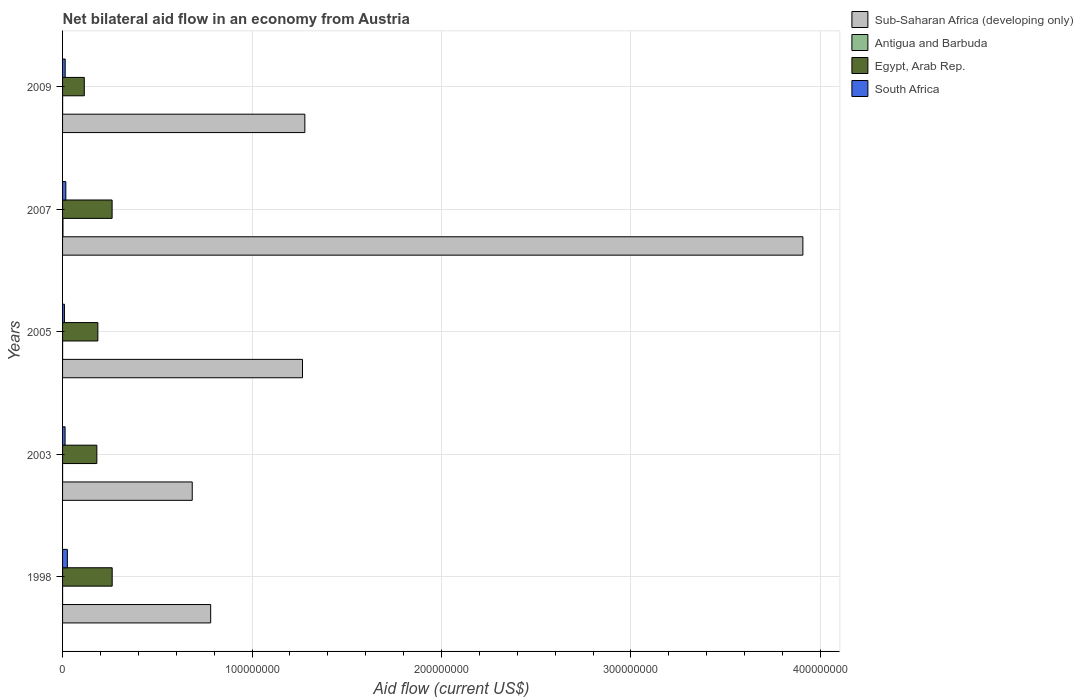How many different coloured bars are there?
Make the answer very short. 4. Are the number of bars per tick equal to the number of legend labels?
Make the answer very short. Yes. Are the number of bars on each tick of the Y-axis equal?
Ensure brevity in your answer.  Yes. How many bars are there on the 3rd tick from the top?
Give a very brief answer. 4. What is the net bilateral aid flow in South Africa in 2005?
Offer a terse response. 9.90e+05. Across all years, what is the maximum net bilateral aid flow in South Africa?
Your response must be concise. 2.54e+06. Across all years, what is the minimum net bilateral aid flow in Antigua and Barbuda?
Offer a terse response. 10000. In which year was the net bilateral aid flow in South Africa maximum?
Your answer should be very brief. 1998. In which year was the net bilateral aid flow in South Africa minimum?
Provide a short and direct response. 2005. What is the total net bilateral aid flow in Egypt, Arab Rep. in the graph?
Ensure brevity in your answer.  1.01e+08. What is the difference between the net bilateral aid flow in South Africa in 2003 and that in 2007?
Keep it short and to the point. -3.90e+05. What is the difference between the net bilateral aid flow in Sub-Saharan Africa (developing only) in 2009 and the net bilateral aid flow in Antigua and Barbuda in 2007?
Keep it short and to the point. 1.28e+08. What is the average net bilateral aid flow in Egypt, Arab Rep. per year?
Make the answer very short. 2.01e+07. In the year 2003, what is the difference between the net bilateral aid flow in Egypt, Arab Rep. and net bilateral aid flow in Antigua and Barbuda?
Keep it short and to the point. 1.81e+07. In how many years, is the net bilateral aid flow in Egypt, Arab Rep. greater than 260000000 US$?
Offer a very short reply. 0. What is the ratio of the net bilateral aid flow in Sub-Saharan Africa (developing only) in 2003 to that in 2009?
Your answer should be compact. 0.54. Is the difference between the net bilateral aid flow in Egypt, Arab Rep. in 2003 and 2005 greater than the difference between the net bilateral aid flow in Antigua and Barbuda in 2003 and 2005?
Give a very brief answer. No. What is the difference between the highest and the second highest net bilateral aid flow in Egypt, Arab Rep.?
Offer a terse response. 4.00e+04. What is the difference between the highest and the lowest net bilateral aid flow in South Africa?
Keep it short and to the point. 1.55e+06. Is the sum of the net bilateral aid flow in Antigua and Barbuda in 1998 and 2003 greater than the maximum net bilateral aid flow in Egypt, Arab Rep. across all years?
Provide a succinct answer. No. What does the 1st bar from the top in 2009 represents?
Provide a short and direct response. South Africa. What does the 3rd bar from the bottom in 2007 represents?
Provide a succinct answer. Egypt, Arab Rep. How many bars are there?
Make the answer very short. 20. Are all the bars in the graph horizontal?
Your response must be concise. Yes. What is the difference between two consecutive major ticks on the X-axis?
Offer a very short reply. 1.00e+08. Are the values on the major ticks of X-axis written in scientific E-notation?
Your answer should be very brief. No. Does the graph contain grids?
Provide a succinct answer. Yes. Where does the legend appear in the graph?
Your response must be concise. Top right. How many legend labels are there?
Make the answer very short. 4. How are the legend labels stacked?
Your answer should be very brief. Vertical. What is the title of the graph?
Make the answer very short. Net bilateral aid flow in an economy from Austria. Does "Mozambique" appear as one of the legend labels in the graph?
Your answer should be compact. No. What is the label or title of the X-axis?
Your answer should be very brief. Aid flow (current US$). What is the label or title of the Y-axis?
Your response must be concise. Years. What is the Aid flow (current US$) in Sub-Saharan Africa (developing only) in 1998?
Give a very brief answer. 7.82e+07. What is the Aid flow (current US$) in Antigua and Barbuda in 1998?
Your response must be concise. 10000. What is the Aid flow (current US$) of Egypt, Arab Rep. in 1998?
Keep it short and to the point. 2.62e+07. What is the Aid flow (current US$) of South Africa in 1998?
Your answer should be compact. 2.54e+06. What is the Aid flow (current US$) of Sub-Saharan Africa (developing only) in 2003?
Keep it short and to the point. 6.84e+07. What is the Aid flow (current US$) in Egypt, Arab Rep. in 2003?
Offer a very short reply. 1.81e+07. What is the Aid flow (current US$) in South Africa in 2003?
Give a very brief answer. 1.33e+06. What is the Aid flow (current US$) in Sub-Saharan Africa (developing only) in 2005?
Make the answer very short. 1.27e+08. What is the Aid flow (current US$) in Antigua and Barbuda in 2005?
Provide a short and direct response. 10000. What is the Aid flow (current US$) in Egypt, Arab Rep. in 2005?
Your answer should be compact. 1.86e+07. What is the Aid flow (current US$) in South Africa in 2005?
Offer a very short reply. 9.90e+05. What is the Aid flow (current US$) in Sub-Saharan Africa (developing only) in 2007?
Provide a succinct answer. 3.91e+08. What is the Aid flow (current US$) of Antigua and Barbuda in 2007?
Keep it short and to the point. 2.10e+05. What is the Aid flow (current US$) of Egypt, Arab Rep. in 2007?
Give a very brief answer. 2.62e+07. What is the Aid flow (current US$) in South Africa in 2007?
Offer a terse response. 1.72e+06. What is the Aid flow (current US$) in Sub-Saharan Africa (developing only) in 2009?
Provide a succinct answer. 1.28e+08. What is the Aid flow (current US$) in Antigua and Barbuda in 2009?
Your answer should be very brief. 2.00e+04. What is the Aid flow (current US$) in Egypt, Arab Rep. in 2009?
Offer a terse response. 1.15e+07. What is the Aid flow (current US$) of South Africa in 2009?
Make the answer very short. 1.38e+06. Across all years, what is the maximum Aid flow (current US$) of Sub-Saharan Africa (developing only)?
Your answer should be compact. 3.91e+08. Across all years, what is the maximum Aid flow (current US$) in Antigua and Barbuda?
Keep it short and to the point. 2.10e+05. Across all years, what is the maximum Aid flow (current US$) in Egypt, Arab Rep.?
Your response must be concise. 2.62e+07. Across all years, what is the maximum Aid flow (current US$) in South Africa?
Ensure brevity in your answer.  2.54e+06. Across all years, what is the minimum Aid flow (current US$) of Sub-Saharan Africa (developing only)?
Your answer should be compact. 6.84e+07. Across all years, what is the minimum Aid flow (current US$) in Egypt, Arab Rep.?
Provide a short and direct response. 1.15e+07. Across all years, what is the minimum Aid flow (current US$) in South Africa?
Ensure brevity in your answer.  9.90e+05. What is the total Aid flow (current US$) of Sub-Saharan Africa (developing only) in the graph?
Your answer should be compact. 7.92e+08. What is the total Aid flow (current US$) in Egypt, Arab Rep. in the graph?
Ensure brevity in your answer.  1.01e+08. What is the total Aid flow (current US$) of South Africa in the graph?
Ensure brevity in your answer.  7.96e+06. What is the difference between the Aid flow (current US$) of Sub-Saharan Africa (developing only) in 1998 and that in 2003?
Make the answer very short. 9.73e+06. What is the difference between the Aid flow (current US$) in Egypt, Arab Rep. in 1998 and that in 2003?
Your response must be concise. 8.10e+06. What is the difference between the Aid flow (current US$) in South Africa in 1998 and that in 2003?
Offer a terse response. 1.21e+06. What is the difference between the Aid flow (current US$) of Sub-Saharan Africa (developing only) in 1998 and that in 2005?
Give a very brief answer. -4.85e+07. What is the difference between the Aid flow (current US$) in Antigua and Barbuda in 1998 and that in 2005?
Give a very brief answer. 0. What is the difference between the Aid flow (current US$) in Egypt, Arab Rep. in 1998 and that in 2005?
Offer a terse response. 7.56e+06. What is the difference between the Aid flow (current US$) of South Africa in 1998 and that in 2005?
Keep it short and to the point. 1.55e+06. What is the difference between the Aid flow (current US$) in Sub-Saharan Africa (developing only) in 1998 and that in 2007?
Keep it short and to the point. -3.13e+08. What is the difference between the Aid flow (current US$) in Egypt, Arab Rep. in 1998 and that in 2007?
Keep it short and to the point. 4.00e+04. What is the difference between the Aid flow (current US$) in South Africa in 1998 and that in 2007?
Keep it short and to the point. 8.20e+05. What is the difference between the Aid flow (current US$) of Sub-Saharan Africa (developing only) in 1998 and that in 2009?
Your response must be concise. -4.97e+07. What is the difference between the Aid flow (current US$) in Egypt, Arab Rep. in 1998 and that in 2009?
Keep it short and to the point. 1.47e+07. What is the difference between the Aid flow (current US$) of South Africa in 1998 and that in 2009?
Keep it short and to the point. 1.16e+06. What is the difference between the Aid flow (current US$) of Sub-Saharan Africa (developing only) in 2003 and that in 2005?
Ensure brevity in your answer.  -5.82e+07. What is the difference between the Aid flow (current US$) in Egypt, Arab Rep. in 2003 and that in 2005?
Your response must be concise. -5.40e+05. What is the difference between the Aid flow (current US$) of South Africa in 2003 and that in 2005?
Keep it short and to the point. 3.40e+05. What is the difference between the Aid flow (current US$) of Sub-Saharan Africa (developing only) in 2003 and that in 2007?
Offer a terse response. -3.22e+08. What is the difference between the Aid flow (current US$) of Antigua and Barbuda in 2003 and that in 2007?
Provide a succinct answer. -2.00e+05. What is the difference between the Aid flow (current US$) of Egypt, Arab Rep. in 2003 and that in 2007?
Provide a short and direct response. -8.06e+06. What is the difference between the Aid flow (current US$) of South Africa in 2003 and that in 2007?
Offer a very short reply. -3.90e+05. What is the difference between the Aid flow (current US$) of Sub-Saharan Africa (developing only) in 2003 and that in 2009?
Make the answer very short. -5.94e+07. What is the difference between the Aid flow (current US$) in Antigua and Barbuda in 2003 and that in 2009?
Offer a terse response. -10000. What is the difference between the Aid flow (current US$) in Egypt, Arab Rep. in 2003 and that in 2009?
Make the answer very short. 6.62e+06. What is the difference between the Aid flow (current US$) in South Africa in 2003 and that in 2009?
Provide a short and direct response. -5.00e+04. What is the difference between the Aid flow (current US$) of Sub-Saharan Africa (developing only) in 2005 and that in 2007?
Provide a short and direct response. -2.64e+08. What is the difference between the Aid flow (current US$) in Antigua and Barbuda in 2005 and that in 2007?
Offer a terse response. -2.00e+05. What is the difference between the Aid flow (current US$) in Egypt, Arab Rep. in 2005 and that in 2007?
Your answer should be very brief. -7.52e+06. What is the difference between the Aid flow (current US$) of South Africa in 2005 and that in 2007?
Give a very brief answer. -7.30e+05. What is the difference between the Aid flow (current US$) in Sub-Saharan Africa (developing only) in 2005 and that in 2009?
Offer a very short reply. -1.24e+06. What is the difference between the Aid flow (current US$) in Egypt, Arab Rep. in 2005 and that in 2009?
Ensure brevity in your answer.  7.16e+06. What is the difference between the Aid flow (current US$) in South Africa in 2005 and that in 2009?
Give a very brief answer. -3.90e+05. What is the difference between the Aid flow (current US$) of Sub-Saharan Africa (developing only) in 2007 and that in 2009?
Offer a terse response. 2.63e+08. What is the difference between the Aid flow (current US$) in Antigua and Barbuda in 2007 and that in 2009?
Your response must be concise. 1.90e+05. What is the difference between the Aid flow (current US$) of Egypt, Arab Rep. in 2007 and that in 2009?
Your answer should be compact. 1.47e+07. What is the difference between the Aid flow (current US$) of Sub-Saharan Africa (developing only) in 1998 and the Aid flow (current US$) of Antigua and Barbuda in 2003?
Make the answer very short. 7.82e+07. What is the difference between the Aid flow (current US$) of Sub-Saharan Africa (developing only) in 1998 and the Aid flow (current US$) of Egypt, Arab Rep. in 2003?
Make the answer very short. 6.01e+07. What is the difference between the Aid flow (current US$) in Sub-Saharan Africa (developing only) in 1998 and the Aid flow (current US$) in South Africa in 2003?
Ensure brevity in your answer.  7.68e+07. What is the difference between the Aid flow (current US$) in Antigua and Barbuda in 1998 and the Aid flow (current US$) in Egypt, Arab Rep. in 2003?
Provide a succinct answer. -1.81e+07. What is the difference between the Aid flow (current US$) in Antigua and Barbuda in 1998 and the Aid flow (current US$) in South Africa in 2003?
Your answer should be compact. -1.32e+06. What is the difference between the Aid flow (current US$) of Egypt, Arab Rep. in 1998 and the Aid flow (current US$) of South Africa in 2003?
Provide a succinct answer. 2.49e+07. What is the difference between the Aid flow (current US$) of Sub-Saharan Africa (developing only) in 1998 and the Aid flow (current US$) of Antigua and Barbuda in 2005?
Keep it short and to the point. 7.82e+07. What is the difference between the Aid flow (current US$) in Sub-Saharan Africa (developing only) in 1998 and the Aid flow (current US$) in Egypt, Arab Rep. in 2005?
Offer a terse response. 5.95e+07. What is the difference between the Aid flow (current US$) of Sub-Saharan Africa (developing only) in 1998 and the Aid flow (current US$) of South Africa in 2005?
Your response must be concise. 7.72e+07. What is the difference between the Aid flow (current US$) in Antigua and Barbuda in 1998 and the Aid flow (current US$) in Egypt, Arab Rep. in 2005?
Offer a terse response. -1.86e+07. What is the difference between the Aid flow (current US$) in Antigua and Barbuda in 1998 and the Aid flow (current US$) in South Africa in 2005?
Make the answer very short. -9.80e+05. What is the difference between the Aid flow (current US$) of Egypt, Arab Rep. in 1998 and the Aid flow (current US$) of South Africa in 2005?
Keep it short and to the point. 2.52e+07. What is the difference between the Aid flow (current US$) of Sub-Saharan Africa (developing only) in 1998 and the Aid flow (current US$) of Antigua and Barbuda in 2007?
Your answer should be compact. 7.80e+07. What is the difference between the Aid flow (current US$) of Sub-Saharan Africa (developing only) in 1998 and the Aid flow (current US$) of Egypt, Arab Rep. in 2007?
Offer a very short reply. 5.20e+07. What is the difference between the Aid flow (current US$) in Sub-Saharan Africa (developing only) in 1998 and the Aid flow (current US$) in South Africa in 2007?
Give a very brief answer. 7.64e+07. What is the difference between the Aid flow (current US$) of Antigua and Barbuda in 1998 and the Aid flow (current US$) of Egypt, Arab Rep. in 2007?
Provide a succinct answer. -2.61e+07. What is the difference between the Aid flow (current US$) in Antigua and Barbuda in 1998 and the Aid flow (current US$) in South Africa in 2007?
Offer a terse response. -1.71e+06. What is the difference between the Aid flow (current US$) in Egypt, Arab Rep. in 1998 and the Aid flow (current US$) in South Africa in 2007?
Your answer should be compact. 2.45e+07. What is the difference between the Aid flow (current US$) of Sub-Saharan Africa (developing only) in 1998 and the Aid flow (current US$) of Antigua and Barbuda in 2009?
Provide a short and direct response. 7.82e+07. What is the difference between the Aid flow (current US$) in Sub-Saharan Africa (developing only) in 1998 and the Aid flow (current US$) in Egypt, Arab Rep. in 2009?
Provide a succinct answer. 6.67e+07. What is the difference between the Aid flow (current US$) in Sub-Saharan Africa (developing only) in 1998 and the Aid flow (current US$) in South Africa in 2009?
Ensure brevity in your answer.  7.68e+07. What is the difference between the Aid flow (current US$) in Antigua and Barbuda in 1998 and the Aid flow (current US$) in Egypt, Arab Rep. in 2009?
Your answer should be very brief. -1.15e+07. What is the difference between the Aid flow (current US$) in Antigua and Barbuda in 1998 and the Aid flow (current US$) in South Africa in 2009?
Provide a short and direct response. -1.37e+06. What is the difference between the Aid flow (current US$) in Egypt, Arab Rep. in 1998 and the Aid flow (current US$) in South Africa in 2009?
Offer a very short reply. 2.48e+07. What is the difference between the Aid flow (current US$) of Sub-Saharan Africa (developing only) in 2003 and the Aid flow (current US$) of Antigua and Barbuda in 2005?
Your response must be concise. 6.84e+07. What is the difference between the Aid flow (current US$) of Sub-Saharan Africa (developing only) in 2003 and the Aid flow (current US$) of Egypt, Arab Rep. in 2005?
Your answer should be compact. 4.98e+07. What is the difference between the Aid flow (current US$) of Sub-Saharan Africa (developing only) in 2003 and the Aid flow (current US$) of South Africa in 2005?
Give a very brief answer. 6.74e+07. What is the difference between the Aid flow (current US$) in Antigua and Barbuda in 2003 and the Aid flow (current US$) in Egypt, Arab Rep. in 2005?
Provide a short and direct response. -1.86e+07. What is the difference between the Aid flow (current US$) in Antigua and Barbuda in 2003 and the Aid flow (current US$) in South Africa in 2005?
Your response must be concise. -9.80e+05. What is the difference between the Aid flow (current US$) of Egypt, Arab Rep. in 2003 and the Aid flow (current US$) of South Africa in 2005?
Keep it short and to the point. 1.71e+07. What is the difference between the Aid flow (current US$) in Sub-Saharan Africa (developing only) in 2003 and the Aid flow (current US$) in Antigua and Barbuda in 2007?
Keep it short and to the point. 6.82e+07. What is the difference between the Aid flow (current US$) of Sub-Saharan Africa (developing only) in 2003 and the Aid flow (current US$) of Egypt, Arab Rep. in 2007?
Give a very brief answer. 4.23e+07. What is the difference between the Aid flow (current US$) of Sub-Saharan Africa (developing only) in 2003 and the Aid flow (current US$) of South Africa in 2007?
Ensure brevity in your answer.  6.67e+07. What is the difference between the Aid flow (current US$) in Antigua and Barbuda in 2003 and the Aid flow (current US$) in Egypt, Arab Rep. in 2007?
Provide a succinct answer. -2.61e+07. What is the difference between the Aid flow (current US$) of Antigua and Barbuda in 2003 and the Aid flow (current US$) of South Africa in 2007?
Your answer should be compact. -1.71e+06. What is the difference between the Aid flow (current US$) of Egypt, Arab Rep. in 2003 and the Aid flow (current US$) of South Africa in 2007?
Provide a short and direct response. 1.64e+07. What is the difference between the Aid flow (current US$) in Sub-Saharan Africa (developing only) in 2003 and the Aid flow (current US$) in Antigua and Barbuda in 2009?
Keep it short and to the point. 6.84e+07. What is the difference between the Aid flow (current US$) of Sub-Saharan Africa (developing only) in 2003 and the Aid flow (current US$) of Egypt, Arab Rep. in 2009?
Keep it short and to the point. 5.70e+07. What is the difference between the Aid flow (current US$) in Sub-Saharan Africa (developing only) in 2003 and the Aid flow (current US$) in South Africa in 2009?
Keep it short and to the point. 6.71e+07. What is the difference between the Aid flow (current US$) in Antigua and Barbuda in 2003 and the Aid flow (current US$) in Egypt, Arab Rep. in 2009?
Ensure brevity in your answer.  -1.15e+07. What is the difference between the Aid flow (current US$) in Antigua and Barbuda in 2003 and the Aid flow (current US$) in South Africa in 2009?
Give a very brief answer. -1.37e+06. What is the difference between the Aid flow (current US$) in Egypt, Arab Rep. in 2003 and the Aid flow (current US$) in South Africa in 2009?
Keep it short and to the point. 1.67e+07. What is the difference between the Aid flow (current US$) of Sub-Saharan Africa (developing only) in 2005 and the Aid flow (current US$) of Antigua and Barbuda in 2007?
Ensure brevity in your answer.  1.26e+08. What is the difference between the Aid flow (current US$) in Sub-Saharan Africa (developing only) in 2005 and the Aid flow (current US$) in Egypt, Arab Rep. in 2007?
Offer a very short reply. 1.00e+08. What is the difference between the Aid flow (current US$) of Sub-Saharan Africa (developing only) in 2005 and the Aid flow (current US$) of South Africa in 2007?
Provide a succinct answer. 1.25e+08. What is the difference between the Aid flow (current US$) in Antigua and Barbuda in 2005 and the Aid flow (current US$) in Egypt, Arab Rep. in 2007?
Your response must be concise. -2.61e+07. What is the difference between the Aid flow (current US$) in Antigua and Barbuda in 2005 and the Aid flow (current US$) in South Africa in 2007?
Give a very brief answer. -1.71e+06. What is the difference between the Aid flow (current US$) in Egypt, Arab Rep. in 2005 and the Aid flow (current US$) in South Africa in 2007?
Give a very brief answer. 1.69e+07. What is the difference between the Aid flow (current US$) of Sub-Saharan Africa (developing only) in 2005 and the Aid flow (current US$) of Antigua and Barbuda in 2009?
Your answer should be compact. 1.27e+08. What is the difference between the Aid flow (current US$) in Sub-Saharan Africa (developing only) in 2005 and the Aid flow (current US$) in Egypt, Arab Rep. in 2009?
Your answer should be compact. 1.15e+08. What is the difference between the Aid flow (current US$) of Sub-Saharan Africa (developing only) in 2005 and the Aid flow (current US$) of South Africa in 2009?
Provide a short and direct response. 1.25e+08. What is the difference between the Aid flow (current US$) in Antigua and Barbuda in 2005 and the Aid flow (current US$) in Egypt, Arab Rep. in 2009?
Provide a succinct answer. -1.15e+07. What is the difference between the Aid flow (current US$) in Antigua and Barbuda in 2005 and the Aid flow (current US$) in South Africa in 2009?
Give a very brief answer. -1.37e+06. What is the difference between the Aid flow (current US$) of Egypt, Arab Rep. in 2005 and the Aid flow (current US$) of South Africa in 2009?
Offer a very short reply. 1.72e+07. What is the difference between the Aid flow (current US$) of Sub-Saharan Africa (developing only) in 2007 and the Aid flow (current US$) of Antigua and Barbuda in 2009?
Give a very brief answer. 3.91e+08. What is the difference between the Aid flow (current US$) of Sub-Saharan Africa (developing only) in 2007 and the Aid flow (current US$) of Egypt, Arab Rep. in 2009?
Give a very brief answer. 3.79e+08. What is the difference between the Aid flow (current US$) of Sub-Saharan Africa (developing only) in 2007 and the Aid flow (current US$) of South Africa in 2009?
Ensure brevity in your answer.  3.89e+08. What is the difference between the Aid flow (current US$) in Antigua and Barbuda in 2007 and the Aid flow (current US$) in Egypt, Arab Rep. in 2009?
Provide a short and direct response. -1.13e+07. What is the difference between the Aid flow (current US$) of Antigua and Barbuda in 2007 and the Aid flow (current US$) of South Africa in 2009?
Your answer should be very brief. -1.17e+06. What is the difference between the Aid flow (current US$) of Egypt, Arab Rep. in 2007 and the Aid flow (current US$) of South Africa in 2009?
Provide a short and direct response. 2.48e+07. What is the average Aid flow (current US$) of Sub-Saharan Africa (developing only) per year?
Provide a short and direct response. 1.58e+08. What is the average Aid flow (current US$) of Antigua and Barbuda per year?
Give a very brief answer. 5.20e+04. What is the average Aid flow (current US$) in Egypt, Arab Rep. per year?
Your answer should be very brief. 2.01e+07. What is the average Aid flow (current US$) of South Africa per year?
Your response must be concise. 1.59e+06. In the year 1998, what is the difference between the Aid flow (current US$) in Sub-Saharan Africa (developing only) and Aid flow (current US$) in Antigua and Barbuda?
Your answer should be compact. 7.82e+07. In the year 1998, what is the difference between the Aid flow (current US$) of Sub-Saharan Africa (developing only) and Aid flow (current US$) of Egypt, Arab Rep.?
Make the answer very short. 5.20e+07. In the year 1998, what is the difference between the Aid flow (current US$) of Sub-Saharan Africa (developing only) and Aid flow (current US$) of South Africa?
Keep it short and to the point. 7.56e+07. In the year 1998, what is the difference between the Aid flow (current US$) of Antigua and Barbuda and Aid flow (current US$) of Egypt, Arab Rep.?
Your answer should be very brief. -2.62e+07. In the year 1998, what is the difference between the Aid flow (current US$) of Antigua and Barbuda and Aid flow (current US$) of South Africa?
Your answer should be very brief. -2.53e+06. In the year 1998, what is the difference between the Aid flow (current US$) of Egypt, Arab Rep. and Aid flow (current US$) of South Africa?
Offer a terse response. 2.36e+07. In the year 2003, what is the difference between the Aid flow (current US$) in Sub-Saharan Africa (developing only) and Aid flow (current US$) in Antigua and Barbuda?
Provide a short and direct response. 6.84e+07. In the year 2003, what is the difference between the Aid flow (current US$) in Sub-Saharan Africa (developing only) and Aid flow (current US$) in Egypt, Arab Rep.?
Keep it short and to the point. 5.04e+07. In the year 2003, what is the difference between the Aid flow (current US$) of Sub-Saharan Africa (developing only) and Aid flow (current US$) of South Africa?
Provide a short and direct response. 6.71e+07. In the year 2003, what is the difference between the Aid flow (current US$) in Antigua and Barbuda and Aid flow (current US$) in Egypt, Arab Rep.?
Your response must be concise. -1.81e+07. In the year 2003, what is the difference between the Aid flow (current US$) of Antigua and Barbuda and Aid flow (current US$) of South Africa?
Provide a short and direct response. -1.32e+06. In the year 2003, what is the difference between the Aid flow (current US$) in Egypt, Arab Rep. and Aid flow (current US$) in South Africa?
Give a very brief answer. 1.68e+07. In the year 2005, what is the difference between the Aid flow (current US$) in Sub-Saharan Africa (developing only) and Aid flow (current US$) in Antigua and Barbuda?
Give a very brief answer. 1.27e+08. In the year 2005, what is the difference between the Aid flow (current US$) in Sub-Saharan Africa (developing only) and Aid flow (current US$) in Egypt, Arab Rep.?
Make the answer very short. 1.08e+08. In the year 2005, what is the difference between the Aid flow (current US$) in Sub-Saharan Africa (developing only) and Aid flow (current US$) in South Africa?
Offer a terse response. 1.26e+08. In the year 2005, what is the difference between the Aid flow (current US$) of Antigua and Barbuda and Aid flow (current US$) of Egypt, Arab Rep.?
Make the answer very short. -1.86e+07. In the year 2005, what is the difference between the Aid flow (current US$) of Antigua and Barbuda and Aid flow (current US$) of South Africa?
Ensure brevity in your answer.  -9.80e+05. In the year 2005, what is the difference between the Aid flow (current US$) in Egypt, Arab Rep. and Aid flow (current US$) in South Africa?
Provide a short and direct response. 1.76e+07. In the year 2007, what is the difference between the Aid flow (current US$) of Sub-Saharan Africa (developing only) and Aid flow (current US$) of Antigua and Barbuda?
Provide a succinct answer. 3.91e+08. In the year 2007, what is the difference between the Aid flow (current US$) in Sub-Saharan Africa (developing only) and Aid flow (current US$) in Egypt, Arab Rep.?
Offer a very short reply. 3.65e+08. In the year 2007, what is the difference between the Aid flow (current US$) of Sub-Saharan Africa (developing only) and Aid flow (current US$) of South Africa?
Provide a short and direct response. 3.89e+08. In the year 2007, what is the difference between the Aid flow (current US$) in Antigua and Barbuda and Aid flow (current US$) in Egypt, Arab Rep.?
Keep it short and to the point. -2.59e+07. In the year 2007, what is the difference between the Aid flow (current US$) in Antigua and Barbuda and Aid flow (current US$) in South Africa?
Offer a terse response. -1.51e+06. In the year 2007, what is the difference between the Aid flow (current US$) in Egypt, Arab Rep. and Aid flow (current US$) in South Africa?
Provide a succinct answer. 2.44e+07. In the year 2009, what is the difference between the Aid flow (current US$) in Sub-Saharan Africa (developing only) and Aid flow (current US$) in Antigua and Barbuda?
Make the answer very short. 1.28e+08. In the year 2009, what is the difference between the Aid flow (current US$) in Sub-Saharan Africa (developing only) and Aid flow (current US$) in Egypt, Arab Rep.?
Offer a very short reply. 1.16e+08. In the year 2009, what is the difference between the Aid flow (current US$) of Sub-Saharan Africa (developing only) and Aid flow (current US$) of South Africa?
Make the answer very short. 1.26e+08. In the year 2009, what is the difference between the Aid flow (current US$) in Antigua and Barbuda and Aid flow (current US$) in Egypt, Arab Rep.?
Keep it short and to the point. -1.14e+07. In the year 2009, what is the difference between the Aid flow (current US$) in Antigua and Barbuda and Aid flow (current US$) in South Africa?
Keep it short and to the point. -1.36e+06. In the year 2009, what is the difference between the Aid flow (current US$) of Egypt, Arab Rep. and Aid flow (current US$) of South Africa?
Your answer should be very brief. 1.01e+07. What is the ratio of the Aid flow (current US$) of Sub-Saharan Africa (developing only) in 1998 to that in 2003?
Give a very brief answer. 1.14. What is the ratio of the Aid flow (current US$) of Antigua and Barbuda in 1998 to that in 2003?
Make the answer very short. 1. What is the ratio of the Aid flow (current US$) in Egypt, Arab Rep. in 1998 to that in 2003?
Your answer should be compact. 1.45. What is the ratio of the Aid flow (current US$) in South Africa in 1998 to that in 2003?
Offer a very short reply. 1.91. What is the ratio of the Aid flow (current US$) in Sub-Saharan Africa (developing only) in 1998 to that in 2005?
Ensure brevity in your answer.  0.62. What is the ratio of the Aid flow (current US$) in Egypt, Arab Rep. in 1998 to that in 2005?
Ensure brevity in your answer.  1.41. What is the ratio of the Aid flow (current US$) of South Africa in 1998 to that in 2005?
Make the answer very short. 2.57. What is the ratio of the Aid flow (current US$) of Sub-Saharan Africa (developing only) in 1998 to that in 2007?
Offer a very short reply. 0.2. What is the ratio of the Aid flow (current US$) in Antigua and Barbuda in 1998 to that in 2007?
Your response must be concise. 0.05. What is the ratio of the Aid flow (current US$) of South Africa in 1998 to that in 2007?
Give a very brief answer. 1.48. What is the ratio of the Aid flow (current US$) in Sub-Saharan Africa (developing only) in 1998 to that in 2009?
Keep it short and to the point. 0.61. What is the ratio of the Aid flow (current US$) in Egypt, Arab Rep. in 1998 to that in 2009?
Make the answer very short. 2.28. What is the ratio of the Aid flow (current US$) of South Africa in 1998 to that in 2009?
Ensure brevity in your answer.  1.84. What is the ratio of the Aid flow (current US$) in Sub-Saharan Africa (developing only) in 2003 to that in 2005?
Ensure brevity in your answer.  0.54. What is the ratio of the Aid flow (current US$) of Egypt, Arab Rep. in 2003 to that in 2005?
Ensure brevity in your answer.  0.97. What is the ratio of the Aid flow (current US$) of South Africa in 2003 to that in 2005?
Make the answer very short. 1.34. What is the ratio of the Aid flow (current US$) in Sub-Saharan Africa (developing only) in 2003 to that in 2007?
Keep it short and to the point. 0.18. What is the ratio of the Aid flow (current US$) of Antigua and Barbuda in 2003 to that in 2007?
Give a very brief answer. 0.05. What is the ratio of the Aid flow (current US$) of Egypt, Arab Rep. in 2003 to that in 2007?
Keep it short and to the point. 0.69. What is the ratio of the Aid flow (current US$) in South Africa in 2003 to that in 2007?
Your answer should be compact. 0.77. What is the ratio of the Aid flow (current US$) in Sub-Saharan Africa (developing only) in 2003 to that in 2009?
Keep it short and to the point. 0.54. What is the ratio of the Aid flow (current US$) of Antigua and Barbuda in 2003 to that in 2009?
Ensure brevity in your answer.  0.5. What is the ratio of the Aid flow (current US$) of Egypt, Arab Rep. in 2003 to that in 2009?
Your response must be concise. 1.58. What is the ratio of the Aid flow (current US$) in South Africa in 2003 to that in 2009?
Give a very brief answer. 0.96. What is the ratio of the Aid flow (current US$) of Sub-Saharan Africa (developing only) in 2005 to that in 2007?
Provide a short and direct response. 0.32. What is the ratio of the Aid flow (current US$) of Antigua and Barbuda in 2005 to that in 2007?
Keep it short and to the point. 0.05. What is the ratio of the Aid flow (current US$) of Egypt, Arab Rep. in 2005 to that in 2007?
Your answer should be very brief. 0.71. What is the ratio of the Aid flow (current US$) in South Africa in 2005 to that in 2007?
Provide a short and direct response. 0.58. What is the ratio of the Aid flow (current US$) of Sub-Saharan Africa (developing only) in 2005 to that in 2009?
Offer a very short reply. 0.99. What is the ratio of the Aid flow (current US$) in Antigua and Barbuda in 2005 to that in 2009?
Your answer should be very brief. 0.5. What is the ratio of the Aid flow (current US$) in Egypt, Arab Rep. in 2005 to that in 2009?
Keep it short and to the point. 1.62. What is the ratio of the Aid flow (current US$) of South Africa in 2005 to that in 2009?
Keep it short and to the point. 0.72. What is the ratio of the Aid flow (current US$) in Sub-Saharan Africa (developing only) in 2007 to that in 2009?
Your response must be concise. 3.06. What is the ratio of the Aid flow (current US$) in Antigua and Barbuda in 2007 to that in 2009?
Offer a very short reply. 10.5. What is the ratio of the Aid flow (current US$) of Egypt, Arab Rep. in 2007 to that in 2009?
Your answer should be very brief. 2.28. What is the ratio of the Aid flow (current US$) of South Africa in 2007 to that in 2009?
Provide a succinct answer. 1.25. What is the difference between the highest and the second highest Aid flow (current US$) of Sub-Saharan Africa (developing only)?
Give a very brief answer. 2.63e+08. What is the difference between the highest and the second highest Aid flow (current US$) of Egypt, Arab Rep.?
Keep it short and to the point. 4.00e+04. What is the difference between the highest and the second highest Aid flow (current US$) in South Africa?
Ensure brevity in your answer.  8.20e+05. What is the difference between the highest and the lowest Aid flow (current US$) in Sub-Saharan Africa (developing only)?
Ensure brevity in your answer.  3.22e+08. What is the difference between the highest and the lowest Aid flow (current US$) of Antigua and Barbuda?
Offer a very short reply. 2.00e+05. What is the difference between the highest and the lowest Aid flow (current US$) in Egypt, Arab Rep.?
Make the answer very short. 1.47e+07. What is the difference between the highest and the lowest Aid flow (current US$) in South Africa?
Offer a very short reply. 1.55e+06. 